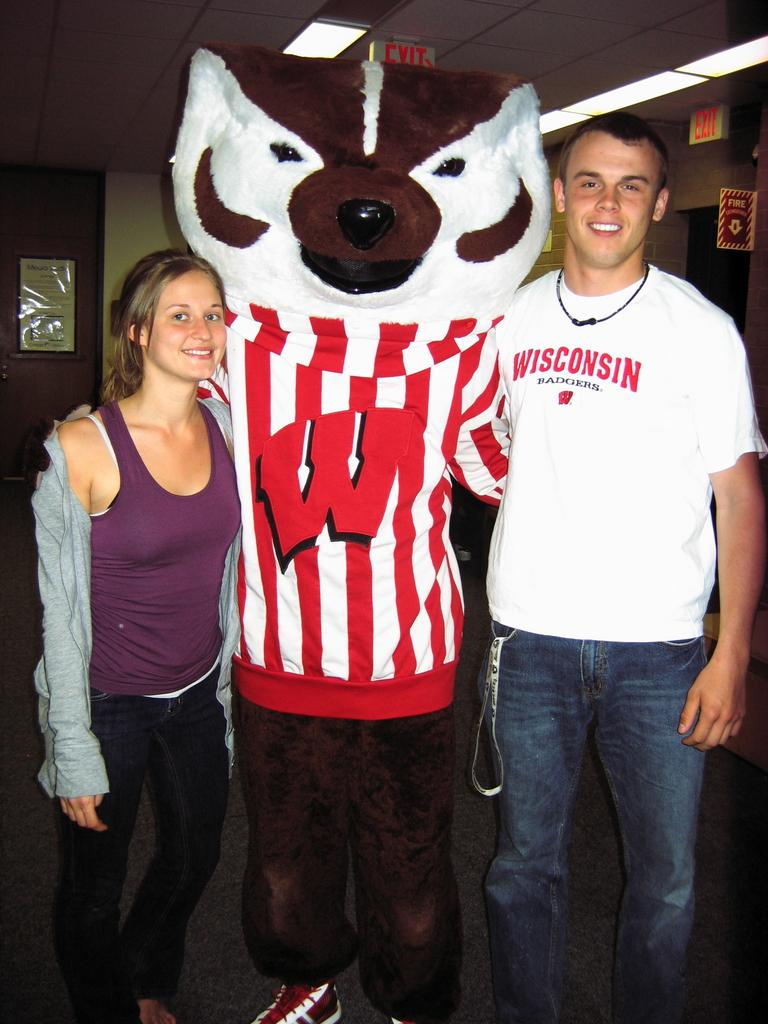<image>
Relay a brief, clear account of the picture shown. Two people stand with a mascot with a big red W on it. 